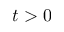Convert formula to latex. <formula><loc_0><loc_0><loc_500><loc_500>t > 0</formula> 